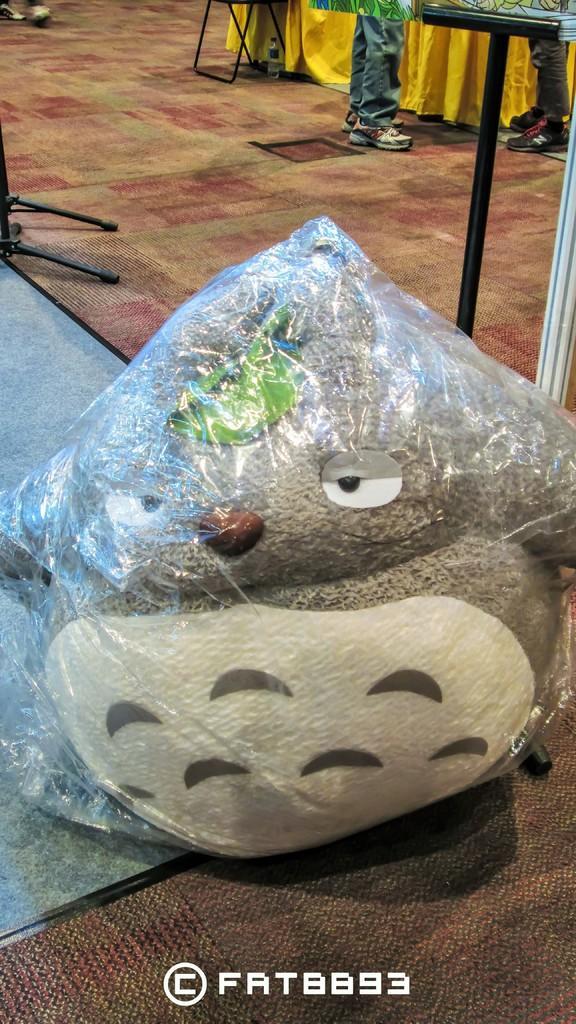Could you give a brief overview of what you see in this image? This image is taken indoors. At the bottom of the image there is a mat on the floor. In the background two persons are standing on the floor. There is a table with a tablecloth. There are a few objects. In the middle of the image there is a teddy bear packed with a cover on the floor. 